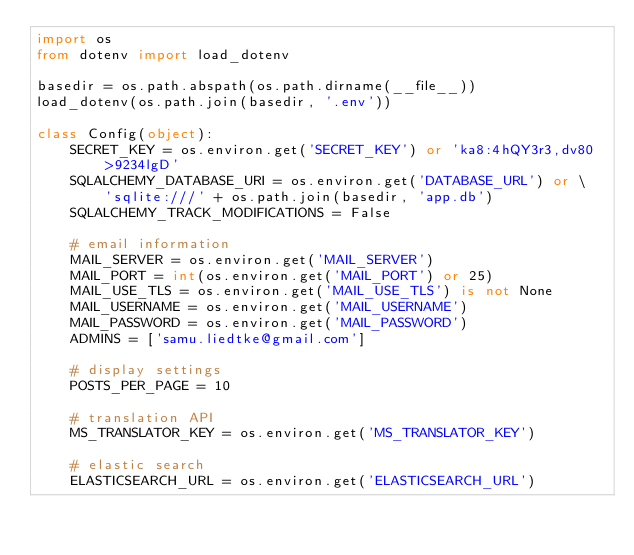<code> <loc_0><loc_0><loc_500><loc_500><_Python_>import os
from dotenv import load_dotenv

basedir = os.path.abspath(os.path.dirname(__file__))
load_dotenv(os.path.join(basedir, '.env'))

class Config(object):
    SECRET_KEY = os.environ.get('SECRET_KEY') or 'ka8:4hQY3r3,dv80>9234lgD'
    SQLALCHEMY_DATABASE_URI = os.environ.get('DATABASE_URL') or \
        'sqlite:///' + os.path.join(basedir, 'app.db')
    SQLALCHEMY_TRACK_MODIFICATIONS = False

    # email information
    MAIL_SERVER = os.environ.get('MAIL_SERVER')
    MAIL_PORT = int(os.environ.get('MAIL_PORT') or 25)
    MAIL_USE_TLS = os.environ.get('MAIL_USE_TLS') is not None
    MAIL_USERNAME = os.environ.get('MAIL_USERNAME')
    MAIL_PASSWORD = os.environ.get('MAIL_PASSWORD')
    ADMINS = ['samu.liedtke@gmail.com']

    # display settings
    POSTS_PER_PAGE = 10

    # translation API
    MS_TRANSLATOR_KEY = os.environ.get('MS_TRANSLATOR_KEY')

    # elastic search
    ELASTICSEARCH_URL = os.environ.get('ELASTICSEARCH_URL')</code> 